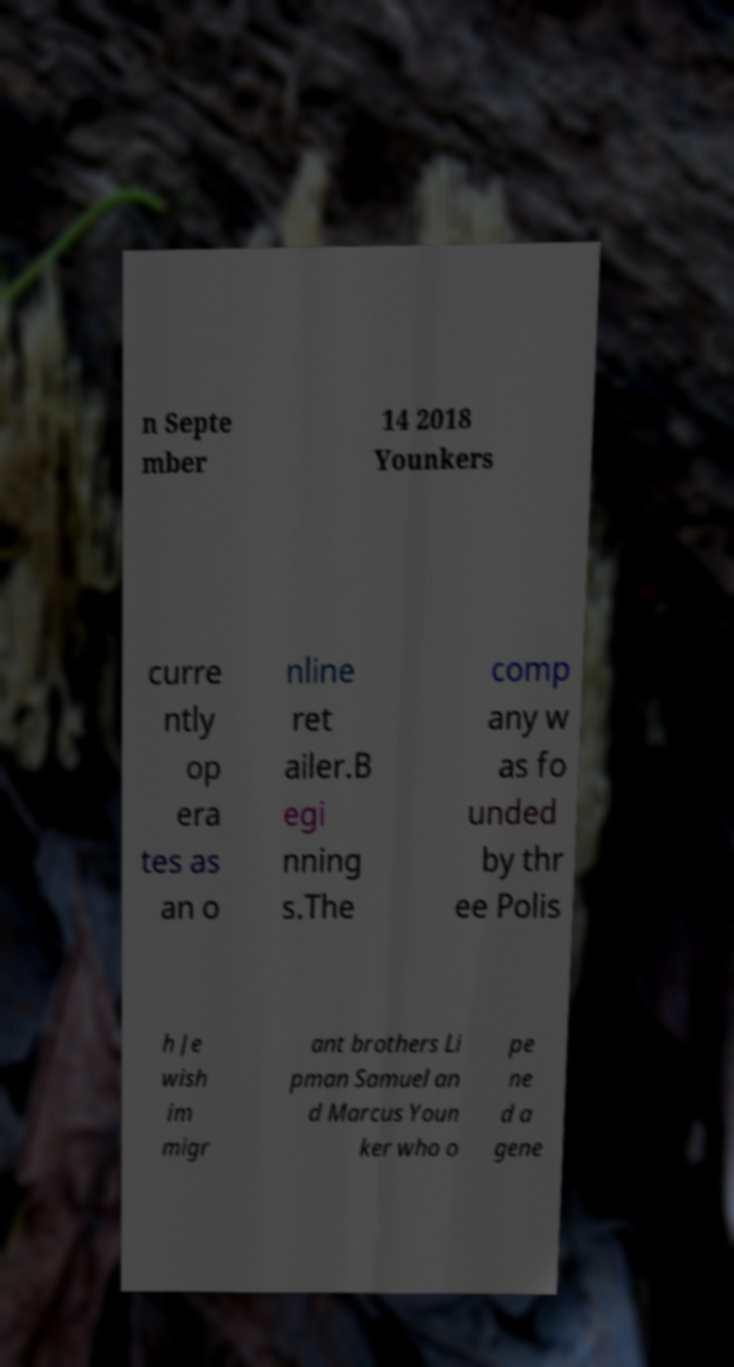Could you assist in decoding the text presented in this image and type it out clearly? n Septe mber 14 2018 Younkers curre ntly op era tes as an o nline ret ailer.B egi nning s.The comp any w as fo unded by thr ee Polis h Je wish im migr ant brothers Li pman Samuel an d Marcus Youn ker who o pe ne d a gene 